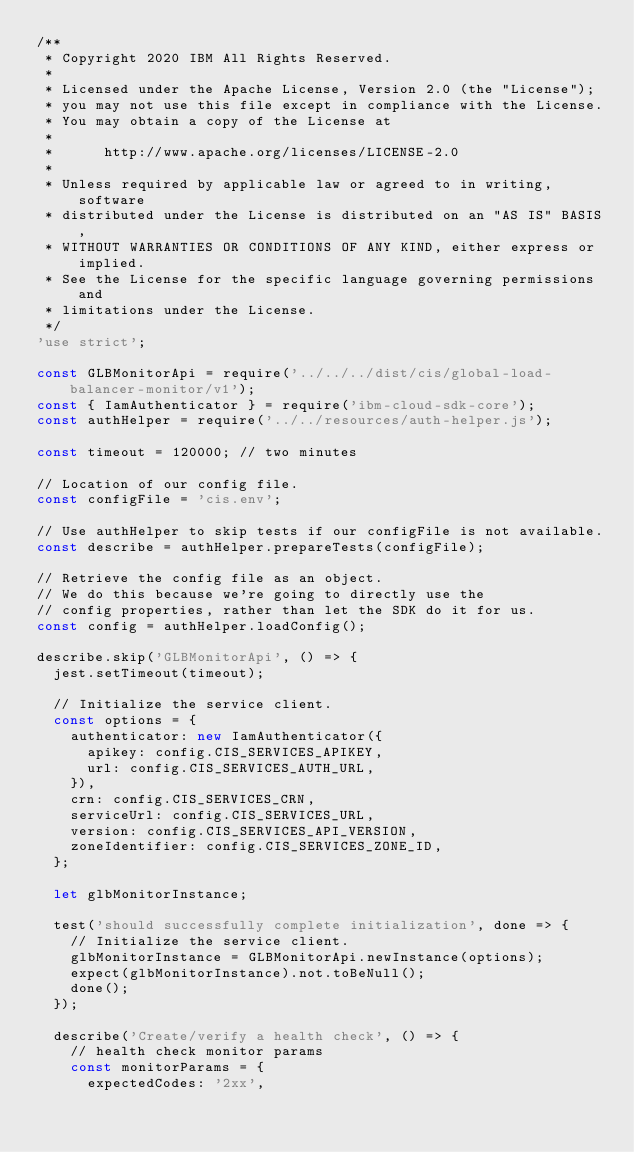Convert code to text. <code><loc_0><loc_0><loc_500><loc_500><_JavaScript_>/**
 * Copyright 2020 IBM All Rights Reserved.
 *
 * Licensed under the Apache License, Version 2.0 (the "License");
 * you may not use this file except in compliance with the License.
 * You may obtain a copy of the License at
 *
 *      http://www.apache.org/licenses/LICENSE-2.0
 *
 * Unless required by applicable law or agreed to in writing, software
 * distributed under the License is distributed on an "AS IS" BASIS,
 * WITHOUT WARRANTIES OR CONDITIONS OF ANY KIND, either express or implied.
 * See the License for the specific language governing permissions and
 * limitations under the License.
 */
'use strict';

const GLBMonitorApi = require('../../../dist/cis/global-load-balancer-monitor/v1');
const { IamAuthenticator } = require('ibm-cloud-sdk-core');
const authHelper = require('../../resources/auth-helper.js');

const timeout = 120000; // two minutes

// Location of our config file.
const configFile = 'cis.env';

// Use authHelper to skip tests if our configFile is not available.
const describe = authHelper.prepareTests(configFile);

// Retrieve the config file as an object.
// We do this because we're going to directly use the
// config properties, rather than let the SDK do it for us.
const config = authHelper.loadConfig();

describe.skip('GLBMonitorApi', () => {
  jest.setTimeout(timeout);

  // Initialize the service client.
  const options = {
    authenticator: new IamAuthenticator({
      apikey: config.CIS_SERVICES_APIKEY,
      url: config.CIS_SERVICES_AUTH_URL,
    }),
    crn: config.CIS_SERVICES_CRN,
    serviceUrl: config.CIS_SERVICES_URL,
    version: config.CIS_SERVICES_API_VERSION,
    zoneIdentifier: config.CIS_SERVICES_ZONE_ID,
  };

  let glbMonitorInstance;

  test('should successfully complete initialization', done => {
    // Initialize the service client.
    glbMonitorInstance = GLBMonitorApi.newInstance(options);
    expect(glbMonitorInstance).not.toBeNull();
    done();
  });

  describe('Create/verify a health check', () => {
    // health check monitor params
    const monitorParams = {
      expectedCodes: '2xx',</code> 